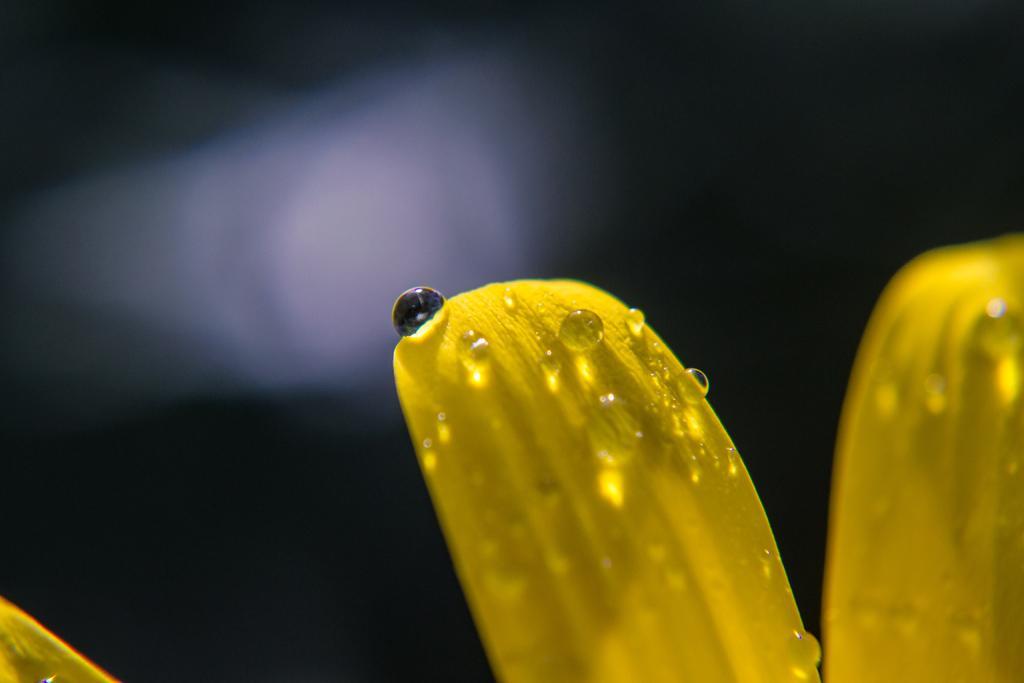How would you summarize this image in a sentence or two? In this picture we can see droplets of water on the petals. Behind the petals, there is the dark background. 